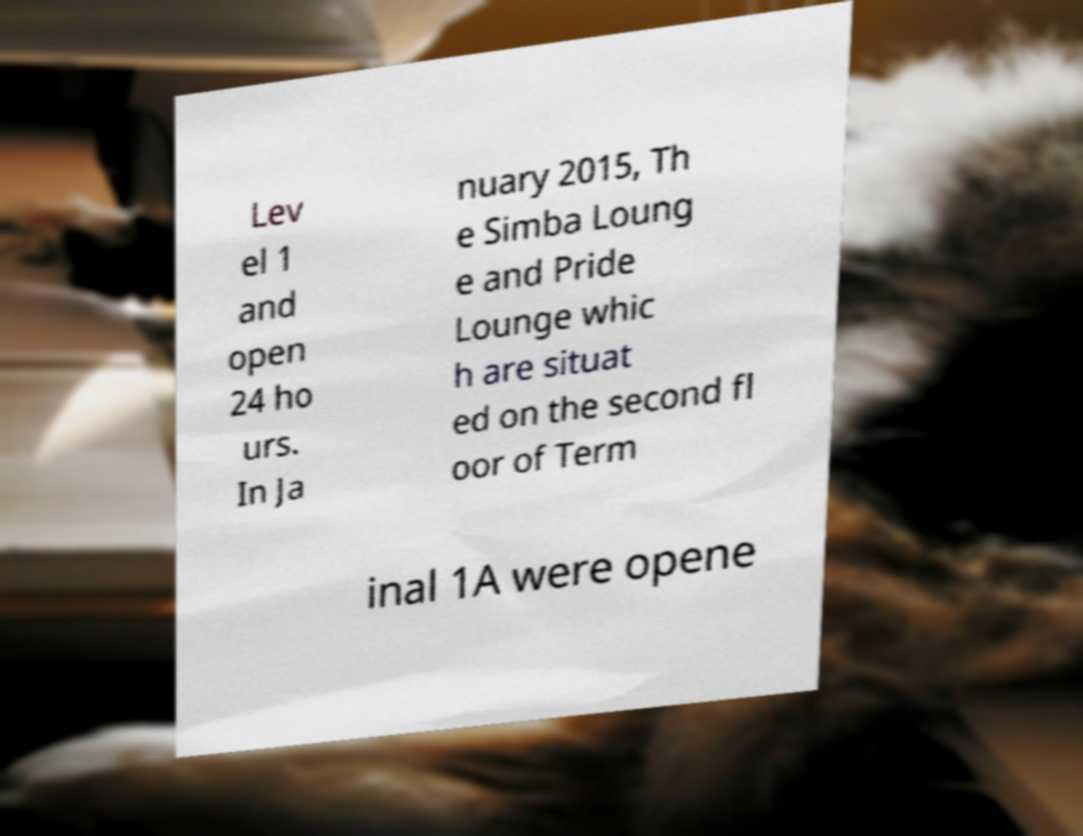What messages or text are displayed in this image? I need them in a readable, typed format. Lev el 1 and open 24 ho urs. In Ja nuary 2015, Th e Simba Loung e and Pride Lounge whic h are situat ed on the second fl oor of Term inal 1A were opene 